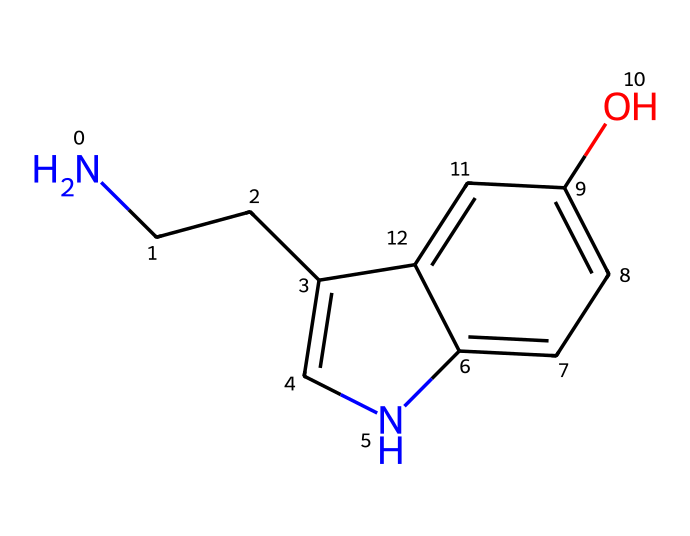What is the main functional group present in serotonin? The molecule contains a hydroxyl group (-OH) attached to an aromatic ring, which characterizes it as a phenol.
Answer: phenol How many carbon atoms are in the molecular structure of serotonin? By analyzing the structure, there are a total of 10 carbon atoms depicted in the chemical representation.
Answer: 10 What is the total number of nitrogen atoms in serotonin? The chemical structure shows one nitrogen atom in the side chain, specifically part of the amine group.
Answer: 1 Does serotonin contain any double bonds? Yes, the molecule has double bonds in the benzene ring that connect carbons and the nitrogen-containing aromatic structure.
Answer: Yes What type of neurotransmitter is serotonin classified as? Serotonin is classified as an amine neurotransmitter due to its amine functional group and role in neurotransmission.
Answer: amine Which part of the serotonin structure is primarily responsible for its role in spiritual experiences? The indole part of the structure influences its interaction with receptors linked to mood and perception, which may tie into spiritual experiences.
Answer: indole 